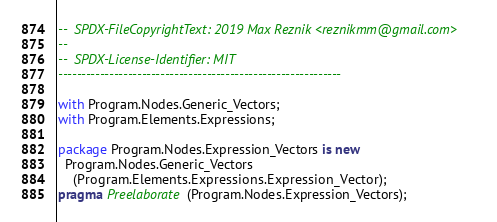Convert code to text. <code><loc_0><loc_0><loc_500><loc_500><_Ada_>--  SPDX-FileCopyrightText: 2019 Max Reznik <reznikmm@gmail.com>
--
--  SPDX-License-Identifier: MIT
-------------------------------------------------------------

with Program.Nodes.Generic_Vectors;
with Program.Elements.Expressions;

package Program.Nodes.Expression_Vectors is new
  Program.Nodes.Generic_Vectors
    (Program.Elements.Expressions.Expression_Vector);
pragma Preelaborate (Program.Nodes.Expression_Vectors);
</code> 